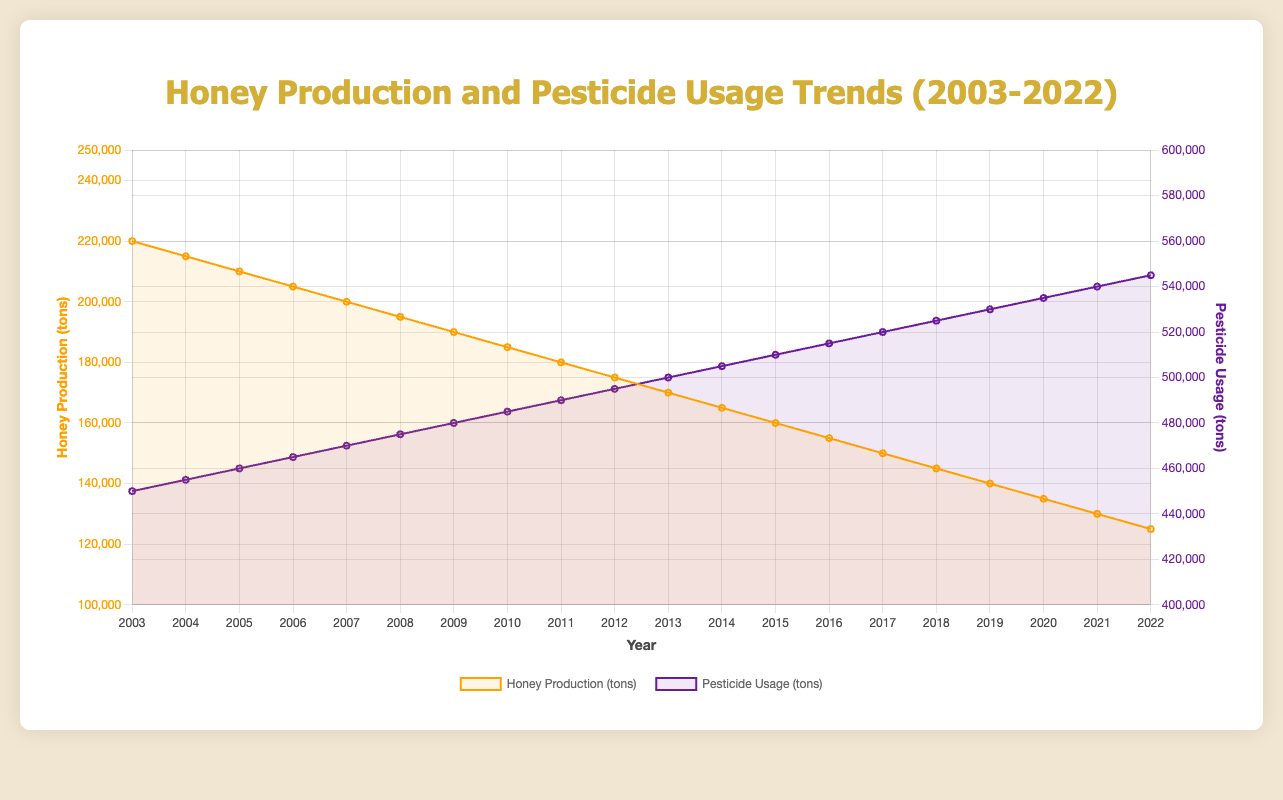What trend can be observed in honey production from 2003 to 2022? The line representing honey production shows a steady decrease from 220,000 tons in 2003 to 125,000 tons in 2022. This indicates a continuous decline in honey production over the 20-year period.
Answer: Steady decline How has pesticide usage changed from 2003 to 2022? The line representing pesticide usage shows a steady increase from 450,000 tons in 2003 to 545,000 tons in 2022. This indicates a continuous rise in pesticide usage over the 20-year period.
Answer: Steady increase What is the difference in honey production between 2003 and 2022? Honey production in 2003 was 220,000 tons and in 2022 it was 125,000 tons. The difference is 220,000 - 125,000 = 95,000 tons.
Answer: 95,000 tons In which year did pesticide usage reach 500,000 tons? By inspecting the pesticide usage trend line, it crosses the 500,000 tons mark in the year 2013.
Answer: 2013 What is the percentage decrease in honey production from 2003 to 2022? The initial production was 220,000 tons and the final production was 125,000 tons. The percentage decrease is calculated as ((220,000 - 125,000) / 220,000) * 100 = 43.18%.
Answer: 43.18% Which year had the highest honey production, and how does it compare to the pesticide usage that year? The highest honey production was in 2003 with 220,000 tons. The pesticide usage that year was 450,000 tons.
Answer: 2003, 450,000 tons What general relationship can be observed between honey production and pesticide usage over the 20 years? As pesticide usage steadily increased, honey production steadily decreased, suggesting a possible negative relationship between the two variables.
Answer: Negative relationship Calculate the average honey production over the 20-year period. The sum of honey production over the 20 years is (220,000 + 215,000 + 210,000 + 205,000 + 200,000 + 195,000 + 190,000 + 185,000 + 180,000 + 175,000 + 170,000 + 165,000 + 160,000 + 155,000 + 150,000 + 145,000 + 140,000 + 135,000 + 130,000 + 125,000) = 3,100,000 tons. The average is 3,100,000 / 20 = 155,000 tons.
Answer: 155,000 tons Compare the rate of change in honey production and pesticide usage. Honey production decreased by (220,000 - 125,000) = 95,000 tons over 20 years, which is an average decrease of 95,000 / 20 = 4,750 tons per year. Pesticide usage increased by (545,000 - 450,000) = 95,000 tons over 20 years, which is an average increase of 95,000 / 20 = 4,750 tons per year. Both rates of change are equal but in opposite directions.
Answer: Equal but opposite What was the honey production in 2015 and how did it compare to pesticide usage in the same year? In 2015, honey production was 160,000 tons, and pesticide usage was 510,000 tons.
Answer: 160,000 tons, 510,000 tons In what years did honey production fall below 150,000 tons? By inspecting the honey production trend line, honey production fell below 150,000 tons starting in 2017 and continued to decrease in subsequent years.
Answer: 2017 onward 